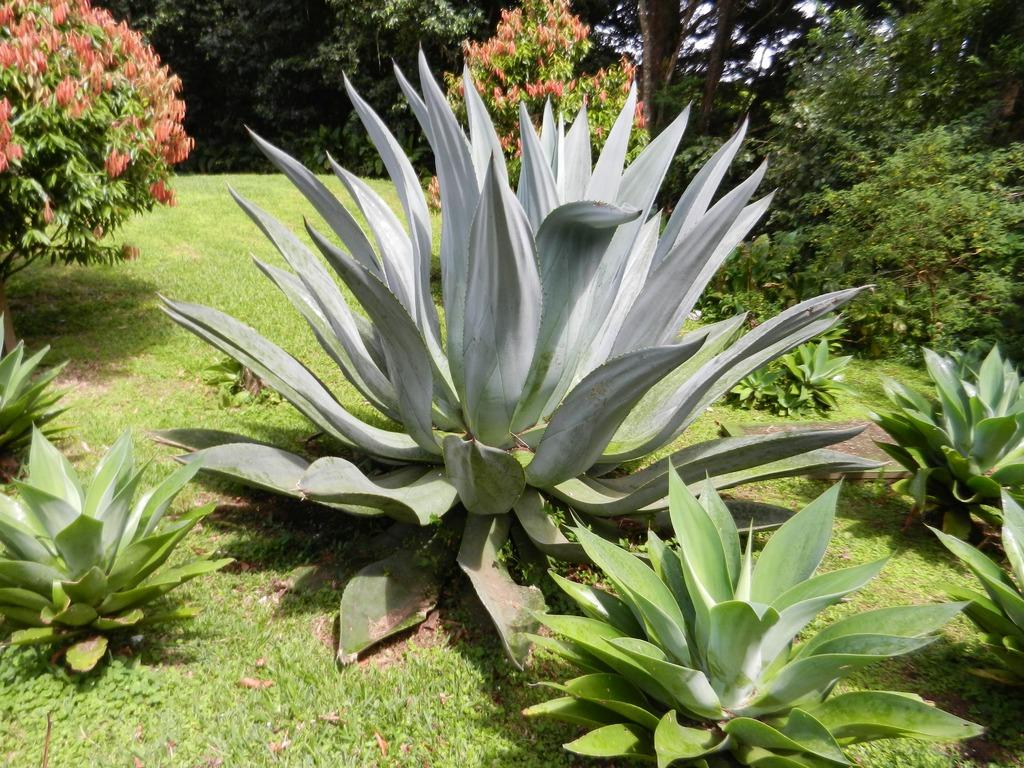What type of vegetation is present at the bottom of the image? There are plants and grass on the ground at the bottom of the image. What can be seen in the distance in the image? There are trees in the background of the image. Are there any plants or grass visible in the background of the image? Yes, there are plants and grass on the ground in the background of the image. What part of the natural environment is visible in the background of the image? The sky is visible in the background of the image. Can you see a ticket or badge hanging from any of the trees in the image? There is no mention of a ticket or badge in the image, and they are not visible in the trees or any other part of the image. Is there any mist present in the image? There is no mention of mist in the image, and it is not visible in the sky or any other part of the image. 